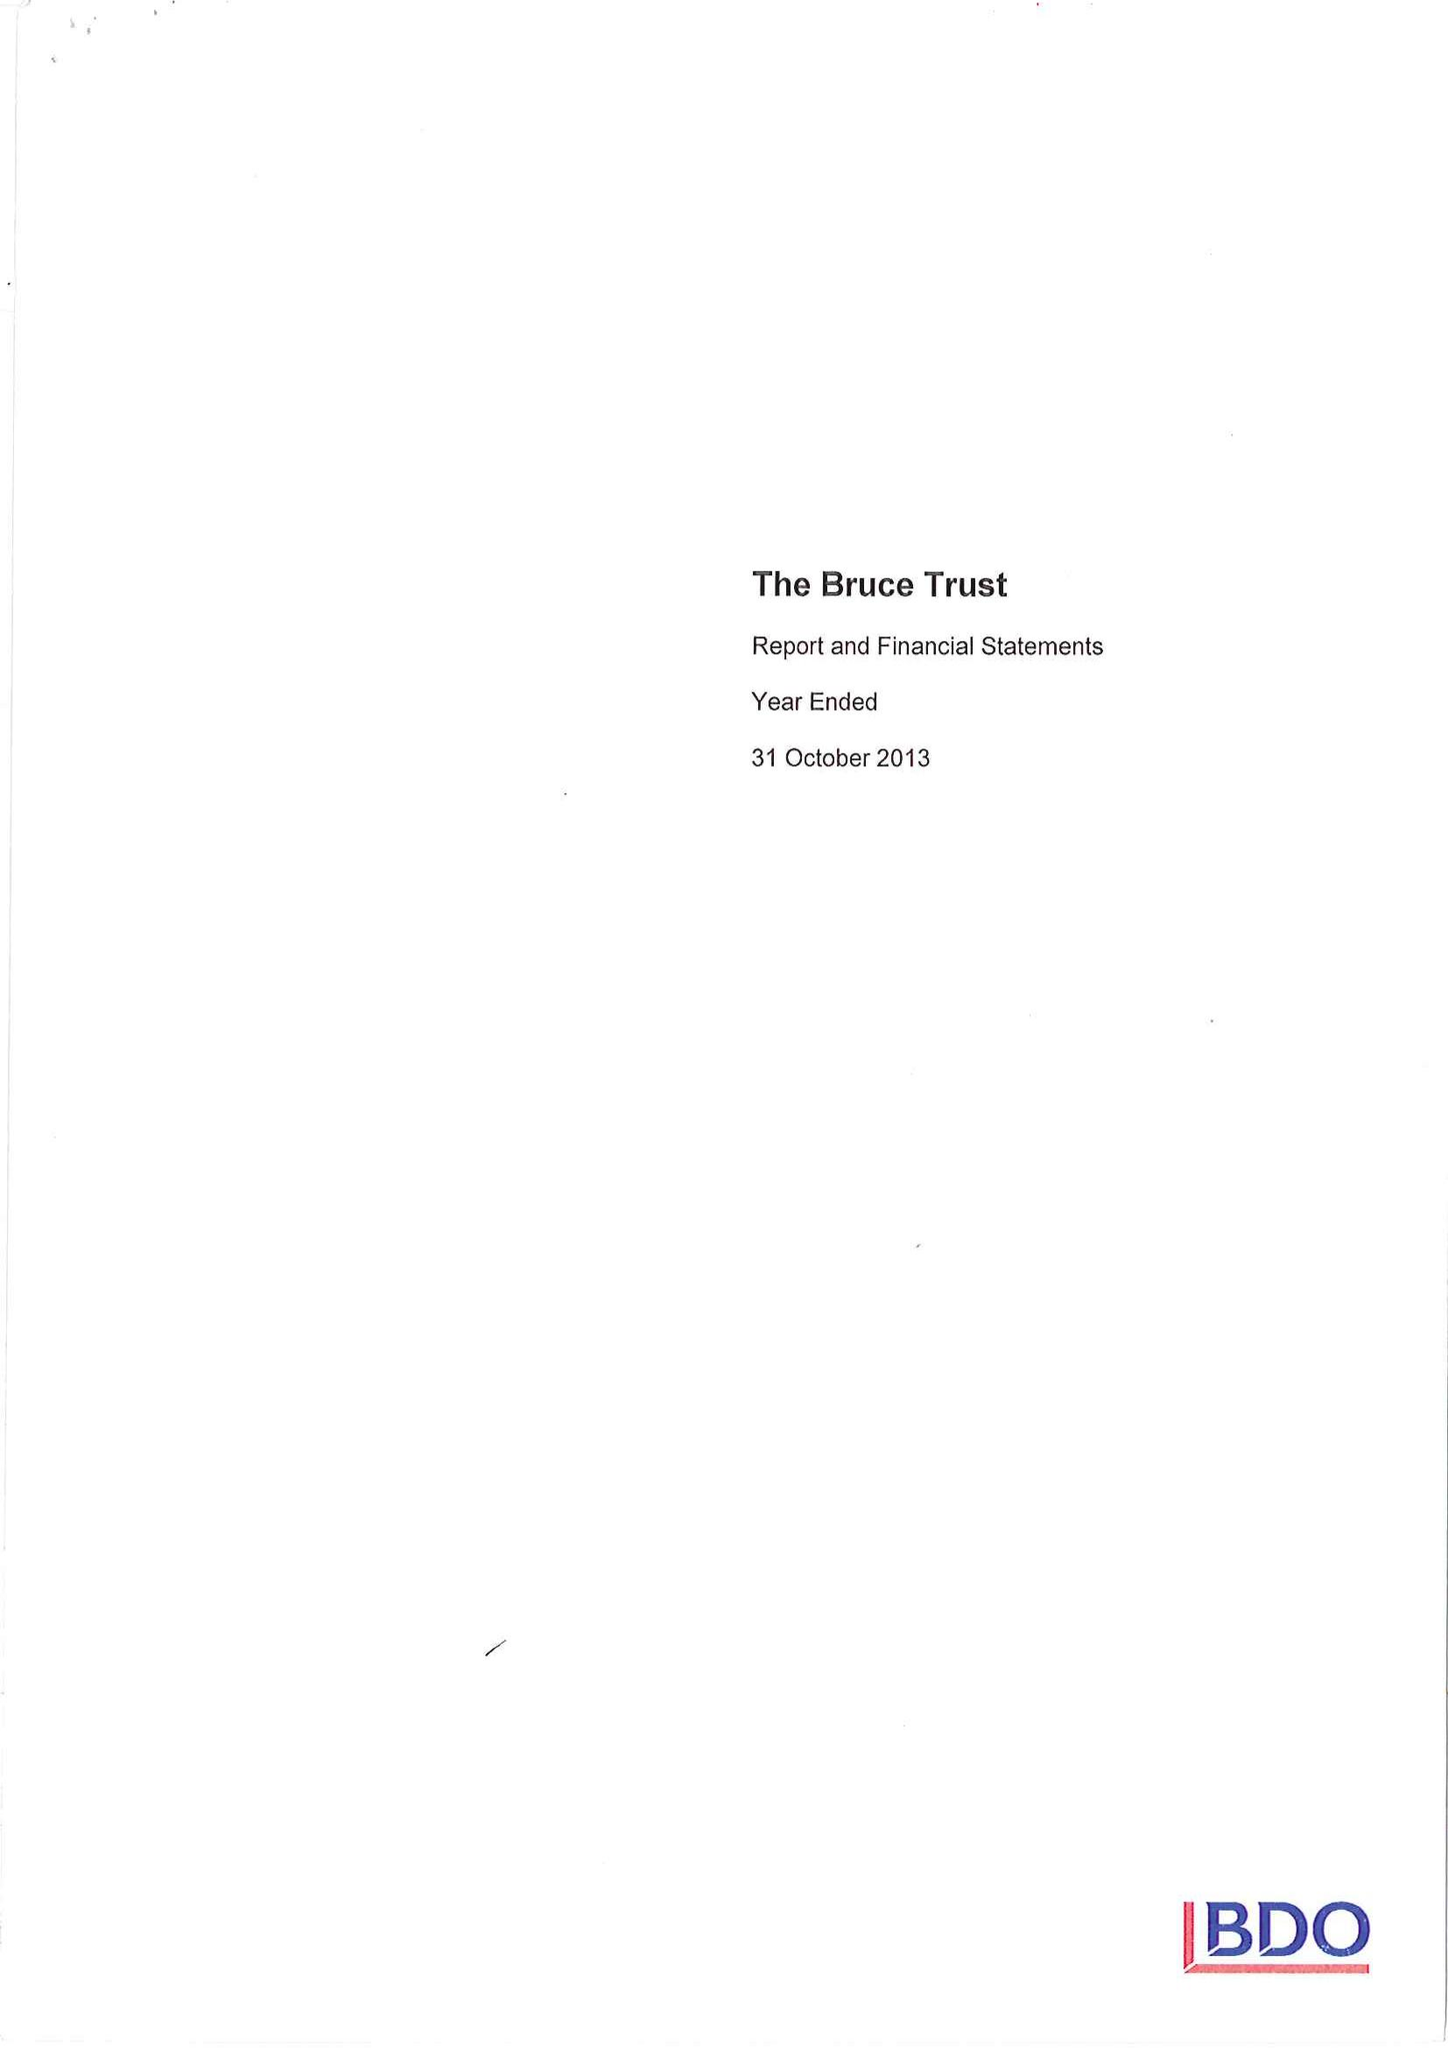What is the value for the address__postcode?
Answer the question using a single word or phrase. RG17 9YY 